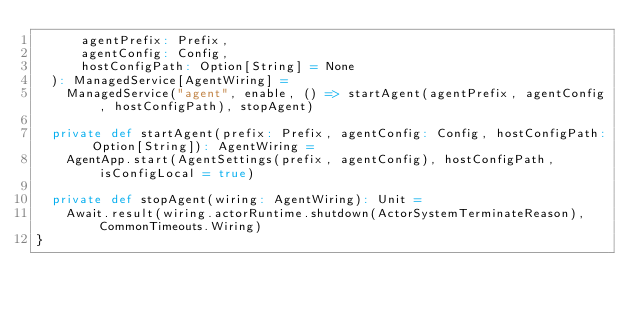Convert code to text. <code><loc_0><loc_0><loc_500><loc_500><_Scala_>      agentPrefix: Prefix,
      agentConfig: Config,
      hostConfigPath: Option[String] = None
  ): ManagedService[AgentWiring] =
    ManagedService("agent", enable, () => startAgent(agentPrefix, agentConfig, hostConfigPath), stopAgent)

  private def startAgent(prefix: Prefix, agentConfig: Config, hostConfigPath: Option[String]): AgentWiring =
    AgentApp.start(AgentSettings(prefix, agentConfig), hostConfigPath, isConfigLocal = true)

  private def stopAgent(wiring: AgentWiring): Unit =
    Await.result(wiring.actorRuntime.shutdown(ActorSystemTerminateReason), CommonTimeouts.Wiring)
}
</code> 